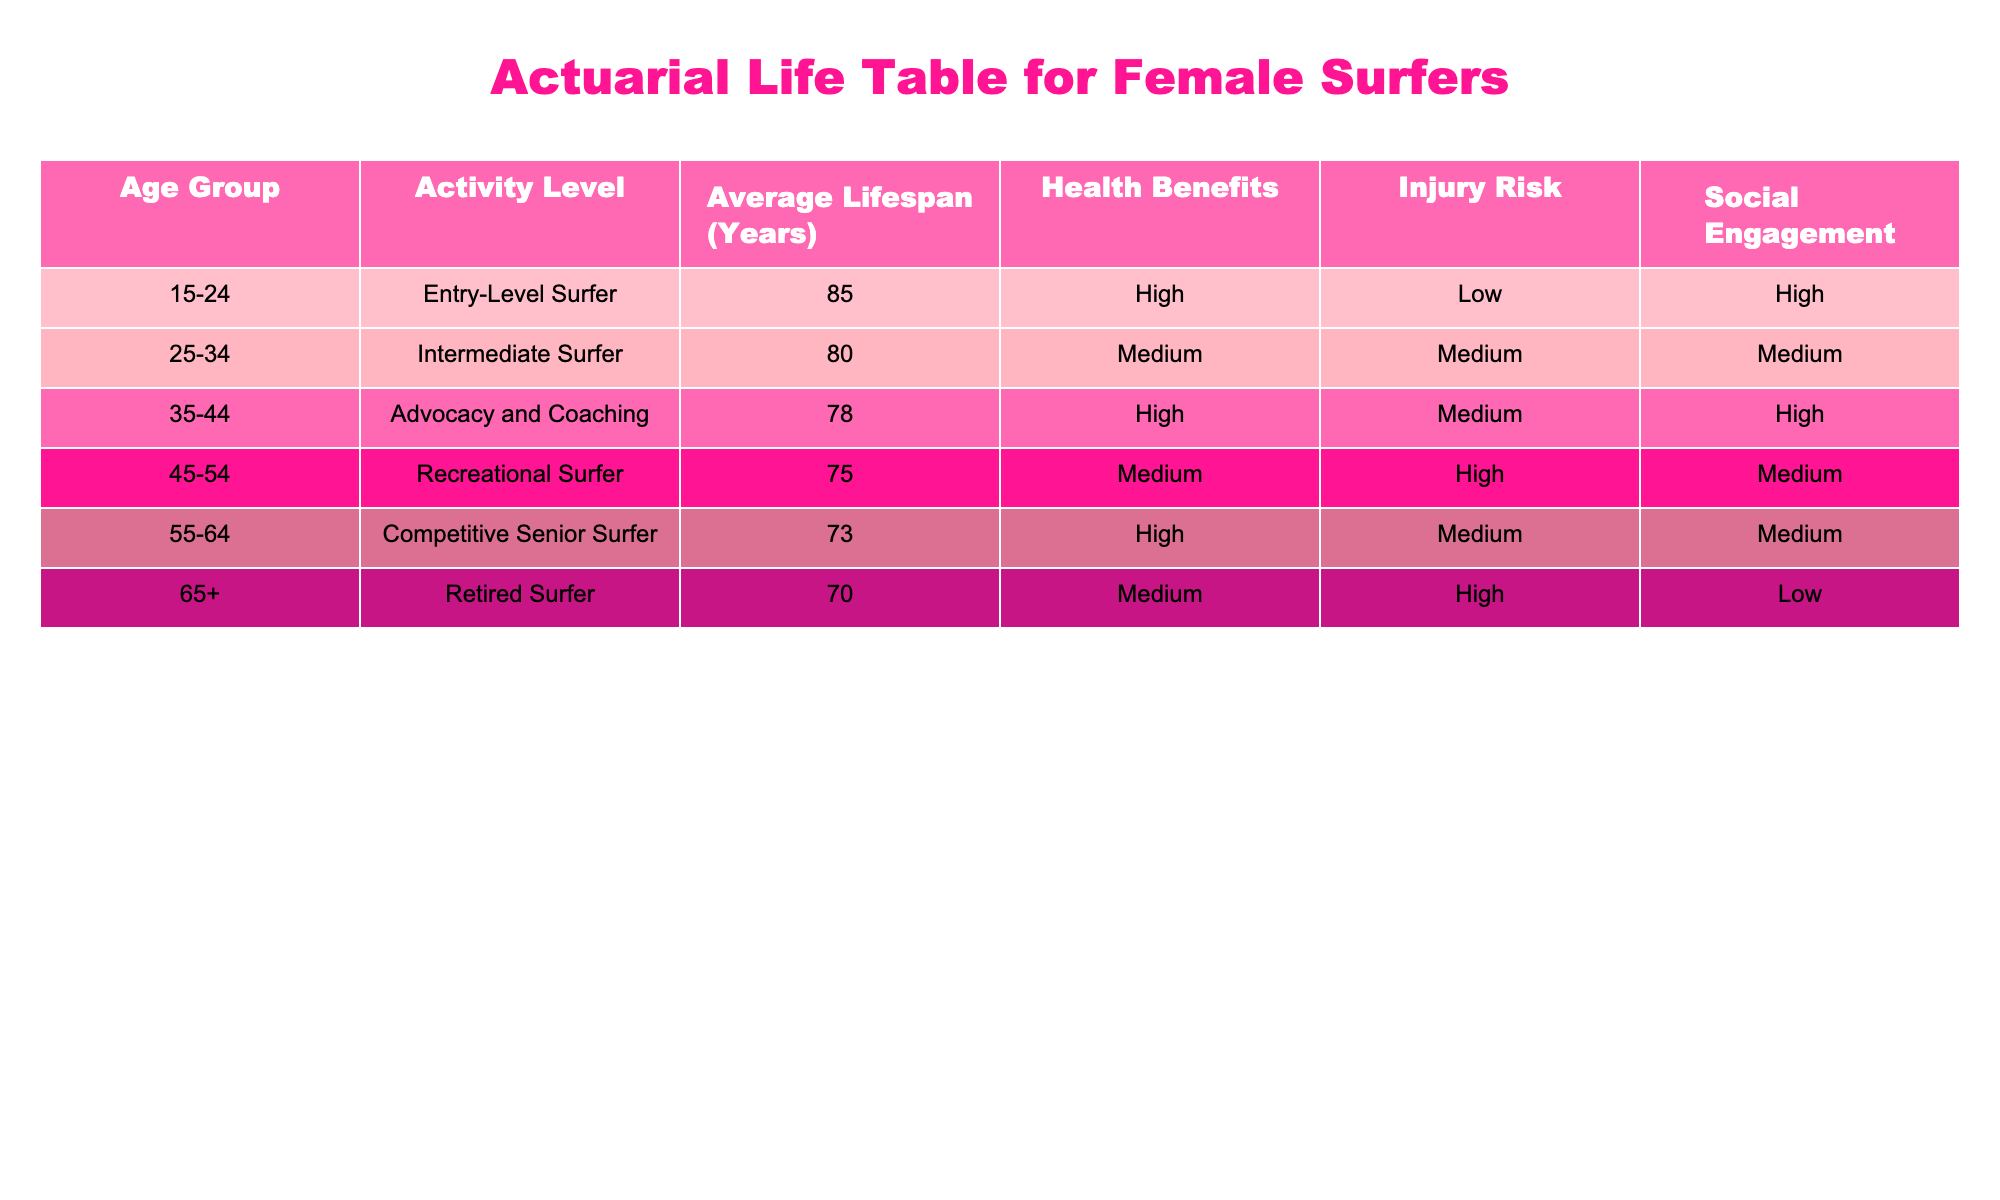What is the average lifespan for an Entry-Level Surfer? From the table, the average lifespan for an Entry-Level Surfer (ages 15-24) is directly listed as 85 years.
Answer: 85 years What is the injury risk level for Recreational Surfers? According to the table, the injury risk for Recreational Surfers (ages 45-54) is categorized as High.
Answer: High Which age group has the lowest average lifespan? The age group with the lowest average lifespan is the Retired Surfer (ages 65+), which has an average lifespan of 70 years.
Answer: 70 years Is the health benefit for Competitive Senior Surfers higher than that for Intermediate Surfers? The table shows that Competitive Senior Surfers have a High health benefit, while Intermediate Surfers have a Medium health benefit. Since High is better than Medium, the statement is true.
Answer: Yes What is the average lifespan difference between Intermediate Surfers and Competitive Senior Surfers? Intermediate Surfers have an average lifespan of 80 years and Competitive Senior Surfers have an average lifespan of 73 years. The difference is 80 - 73 = 7 years.
Answer: 7 years Do both Advocacy and Coaching and Recreational Surfing have the same injury risk level? The table lists Advocacy and Coaching with a Medium injury risk and Recreational Surfers with a High injury risk. Therefore, the two activities do not have the same injury risk level.
Answer: No What is the total average lifespan of all age groups listed in the table? The average lifespans for all age groups are 85, 80, 78, 75, 73, and 70. Summing them gives 85 + 80 + 78 + 75 + 73 + 70 = 461 years. Dividing by the number of groups (6) gives an average lifespan of 461 / 6 = 76.83 years.
Answer: 76.83 years In which category does the highest level of social engagement fall? The table indicates that Entry-Level Surfers have a High level of social engagement. This is the only activity with a High rating in that category.
Answer: Entry-Level Surfers Which age group has a medium level of social engagement? According to the table, both Intermediate Surfers and Recreational Surfers have a Medium level of social engagement.
Answer: Intermediate Surfers and Recreational Surfers 